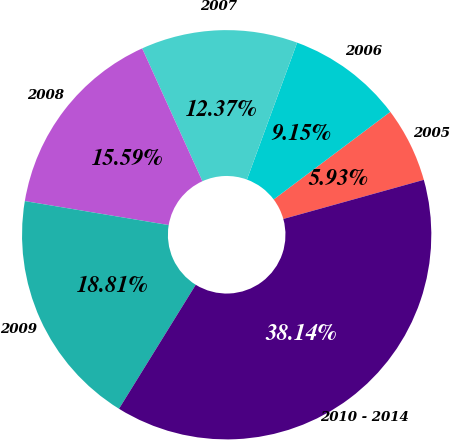Convert chart to OTSL. <chart><loc_0><loc_0><loc_500><loc_500><pie_chart><fcel>2005<fcel>2006<fcel>2007<fcel>2008<fcel>2009<fcel>2010 - 2014<nl><fcel>5.93%<fcel>9.15%<fcel>12.37%<fcel>15.59%<fcel>18.81%<fcel>38.14%<nl></chart> 